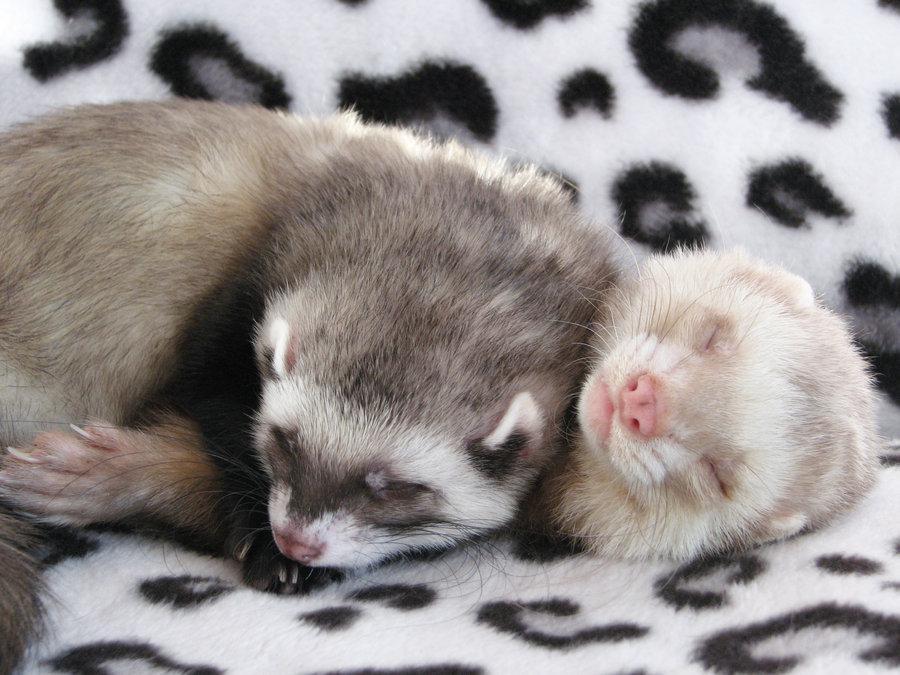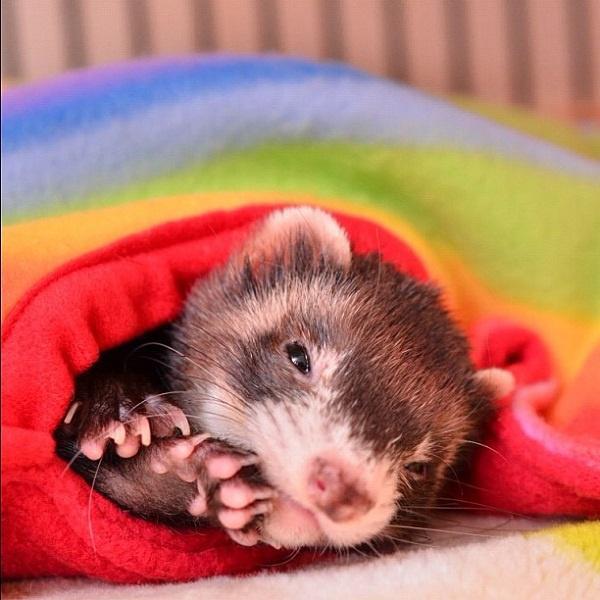The first image is the image on the left, the second image is the image on the right. Given the left and right images, does the statement "There is at least one white ferreton a blanket with another ferret." hold true? Answer yes or no. Yes. The first image is the image on the left, the second image is the image on the right. Evaluate the accuracy of this statement regarding the images: "There is one ferret in the right image with its eyes closed.". Is it true? Answer yes or no. No. 